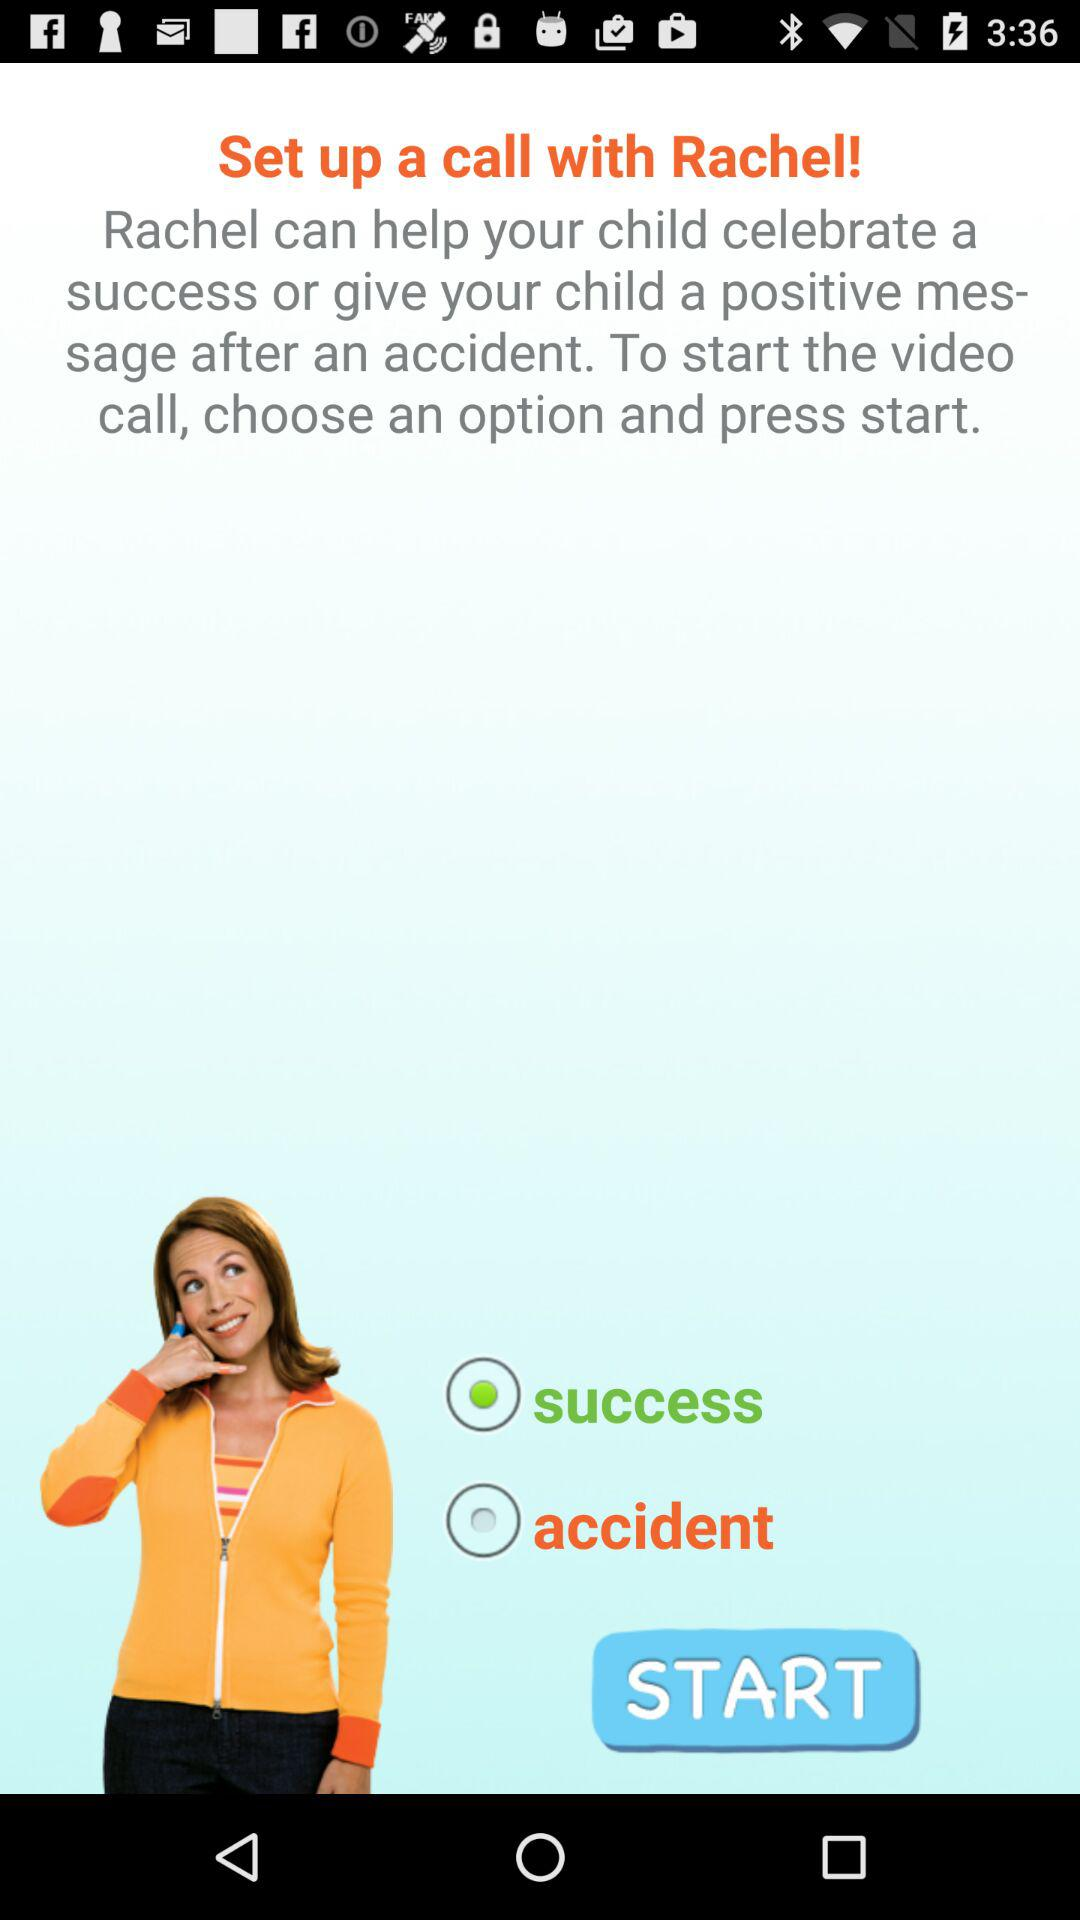Which is the selected option? The selected option is "success". 